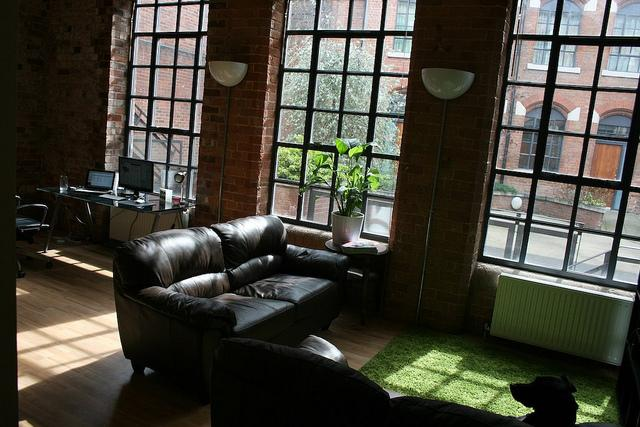Which two species often share this space? Please explain your reasoning. humans dogs. You can tell by the picture of the dog that he occupies this space with a owner. 